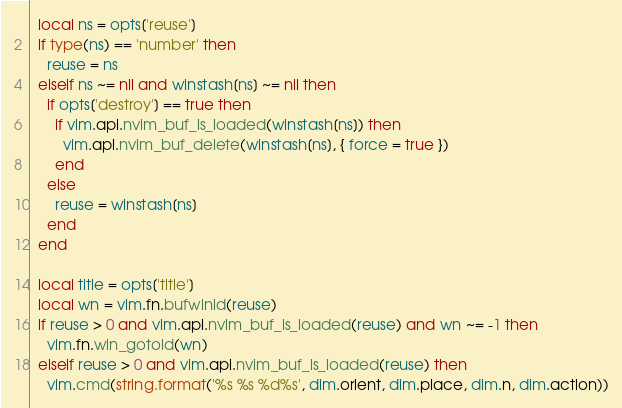<code> <loc_0><loc_0><loc_500><loc_500><_Lua_>  local ns = opts['reuse']
  if type(ns) == 'number' then
    reuse = ns
  elseif ns ~= nil and winstash[ns] ~= nil then
    if opts['destroy'] == true then
      if vim.api.nvim_buf_is_loaded(winstash[ns]) then
        vim.api.nvim_buf_delete(winstash[ns], { force = true })
      end
    else
      reuse = winstash[ns]
    end
  end

  local title = opts['title']
  local wn = vim.fn.bufwinid(reuse)
  if reuse > 0 and vim.api.nvim_buf_is_loaded(reuse) and wn ~= -1 then
    vim.fn.win_gotoid(wn)
  elseif reuse > 0 and vim.api.nvim_buf_is_loaded(reuse) then
    vim.cmd(string.format('%s %s %d%s', dim.orient, dim.place, dim.n, dim.action))</code> 